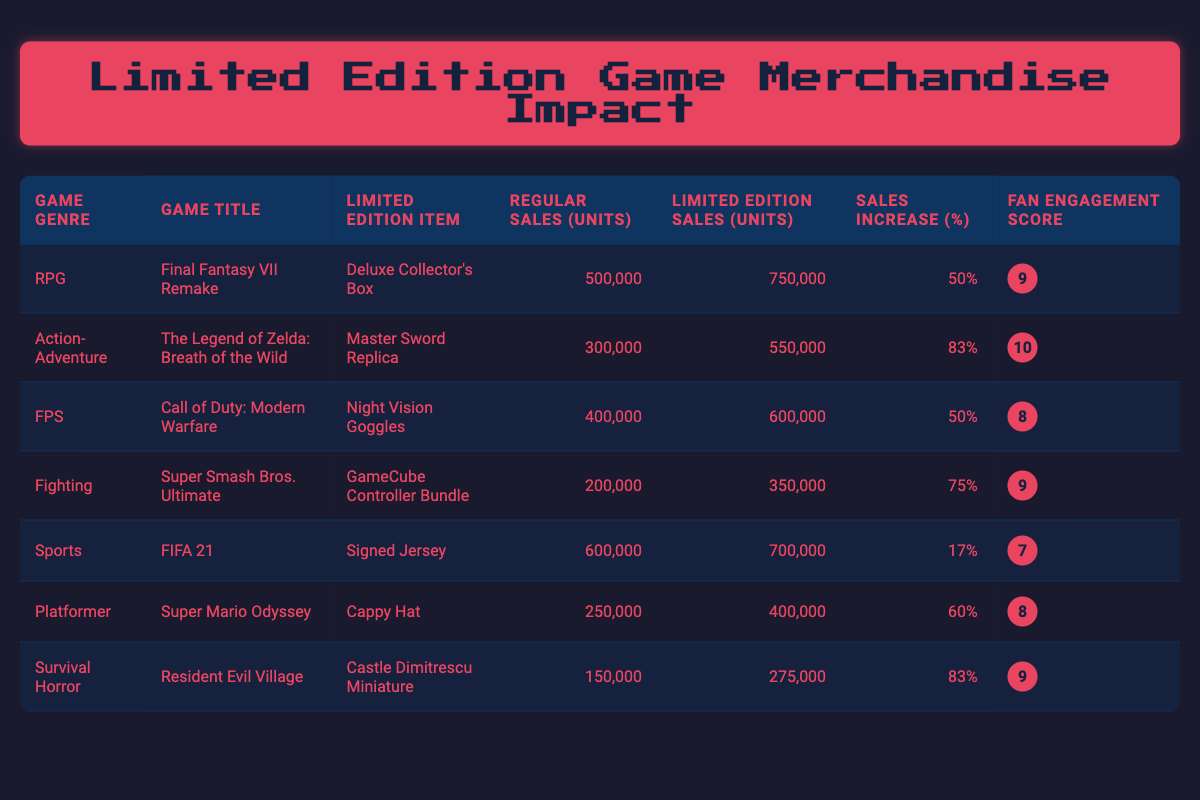What is the limited edition item for "Final Fantasy VII Remake"? The table lists "Deluxe Collector's Box" as the limited edition item for "Final Fantasy VII Remake" under the "Limited Edition Item" column.
Answer: Deluxe Collector's Box What is the sales increase percentage for "The Legend of Zelda: Breath of the Wild"? The sales increase percentage is accessible directly from the table, where it is stated as 83% in the "Sales Increase (%)" column next to the game's title.
Answer: 83% Which game genre had the highest fan engagement score? By comparing the "Fan Engagement Score" column, "The Legend of Zelda: Breath of the Wild" has a score of 10, which is the highest among all entries.
Answer: Action-Adventure What is the total regular sales (units) across all game genres? Adding the regular sales (units) from each row: 500,000 (RPG) + 300,000 (Action-Adventure) + 400,000 (FPS) + 200,000 (Fighting) + 600,000 (Sports) + 250,000 (Platformer) + 150,000 (Survival Horror) gives a total of 2,400,000 units.
Answer: 2,400,000 Is there a game with a limited edition item that has a lower sales increase than "FIFA 21"? "FIFA 21" has a sales increase of 17%. By examining the sales increase percentages, the item with a lower increase is "Signed Jersey", which is indeed the lowest value.
Answer: Yes Which game had the lowest regular sales? Looking at the "Regular Sales (Units)" column, "Resident Evil Village" has the lowest value of 150,000 units, making it the game with the least regular sales.
Answer: Resident Evil Village What is the difference in units sold between the limited and regular edition for "Super Smash Bros. Ultimate"? To find the difference, subtract the regular sales (units) from the limited edition sales (units): 350,000 - 200,000 = 150,000.
Answer: 150,000 Which game has an equal or higher fan engagement score compared to "FIFA 21"? "FIFA 21" has a fan engagement score of 7. The games with scores equal to or higher than this include "Final Fantasy VII Remake" (9), "The Legend of Zelda: Breath of the Wild" (10), "Super Smash Bros. Ultimate" (9), and "Resident Evil Village" (9).
Answer: Final Fantasy VII Remake, The Legend of Zelda: Breath of the Wild, Super Smash Bros. Ultimate, Resident Evil Village 